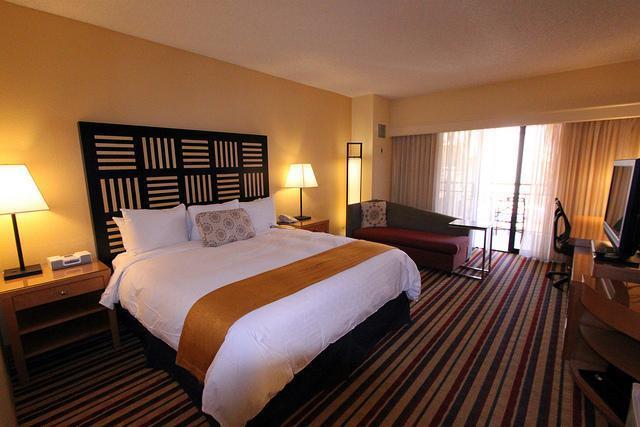How many pillows are on the bed?
Give a very brief answer. 7. How many lamps are on?
Give a very brief answer. 2. How many beds are in the picture?
Give a very brief answer. 1. How many sinks are there?
Give a very brief answer. 0. 